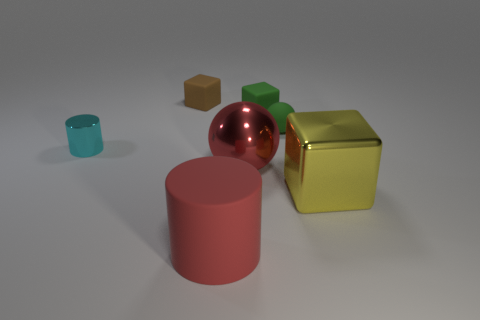Subtract 1 cubes. How many cubes are left? 2 Add 2 tiny cyan objects. How many objects exist? 9 Subtract all spheres. How many objects are left? 5 Subtract all brown cylinders. Subtract all metallic things. How many objects are left? 4 Add 6 large yellow shiny cubes. How many large yellow shiny cubes are left? 7 Add 4 tiny brown objects. How many tiny brown objects exist? 5 Subtract 0 purple cylinders. How many objects are left? 7 